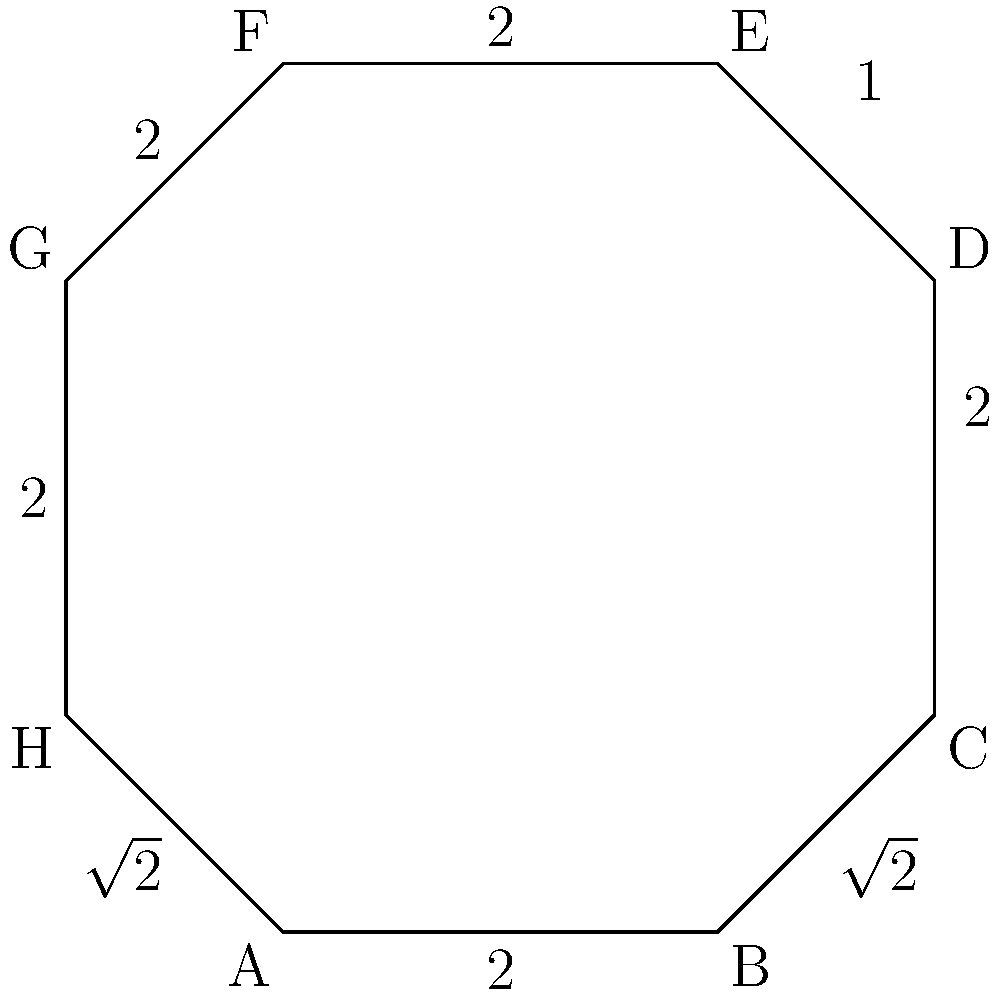In the latest episode of "The Tycoon's Boardroom," Gong Jun's character is seated at an octagonal conference table. The table's dimensions are shown in the diagram, with some sides measuring 2 units, others 1 unit, and the diagonal sides measuring $\sqrt{2}$ units. What is the perimeter of this stylish boardroom table? Let's calculate the perimeter step by step:

1) First, let's count the number of sides for each length:
   - 4 sides of length 2 units
   - 1 side of length 1 unit
   - 2 sides of length $\sqrt{2}$ units

2) Now, let's add up all these lengths:
   $$ \text{Perimeter} = (4 \times 2) + (1 \times 1) + (2 \times \sqrt{2}) $$

3) Simplify:
   $$ \text{Perimeter} = 8 + 1 + 2\sqrt{2} $$

4) Combine like terms:
   $$ \text{Perimeter} = 9 + 2\sqrt{2} $$

This is the exact perimeter. If we wanted to approximate it, we could calculate:
$$ 9 + 2\sqrt{2} \approx 9 + 2(1.414) \approx 11.828 \text{ units} $$

But for the precise answer, we'll leave it in its exact form.
Answer: $9 + 2\sqrt{2}$ units 